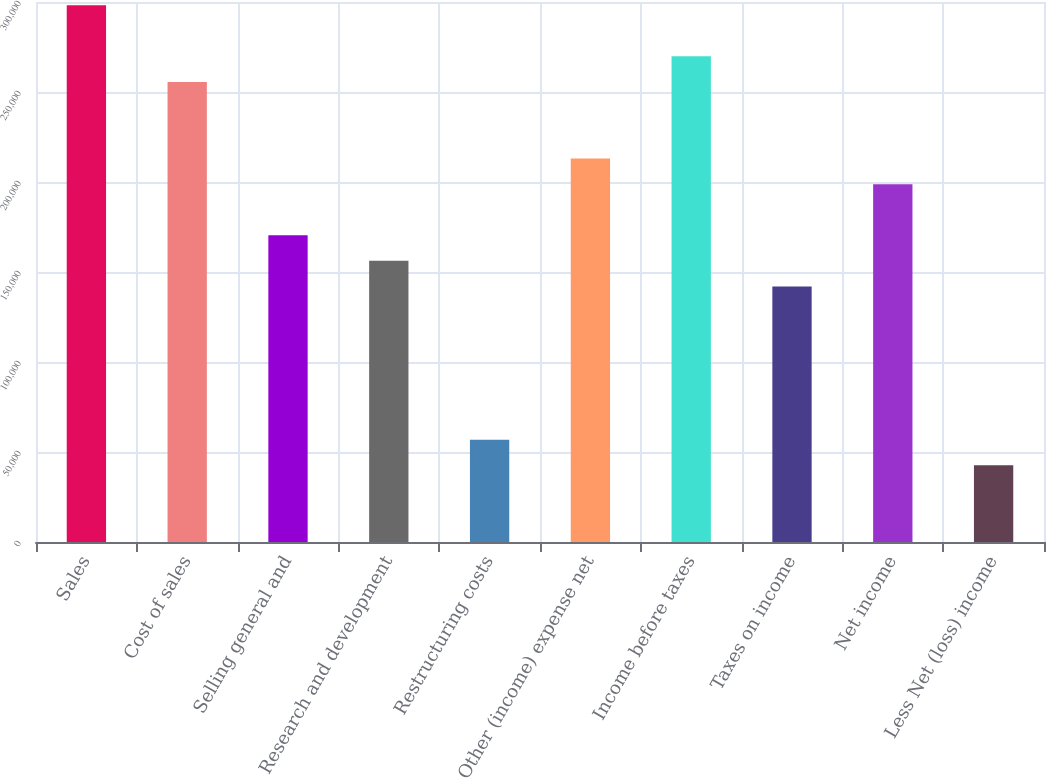Convert chart to OTSL. <chart><loc_0><loc_0><loc_500><loc_500><bar_chart><fcel>Sales<fcel>Cost of sales<fcel>Selling general and<fcel>Research and development<fcel>Restructuring costs<fcel>Other (income) expense net<fcel>Income before taxes<fcel>Taxes on income<fcel>Net income<fcel>Less Net (loss) income<nl><fcel>298198<fcel>255599<fcel>170400<fcel>156200<fcel>56801.1<fcel>212999<fcel>269798<fcel>142000<fcel>198799<fcel>42601.2<nl></chart> 